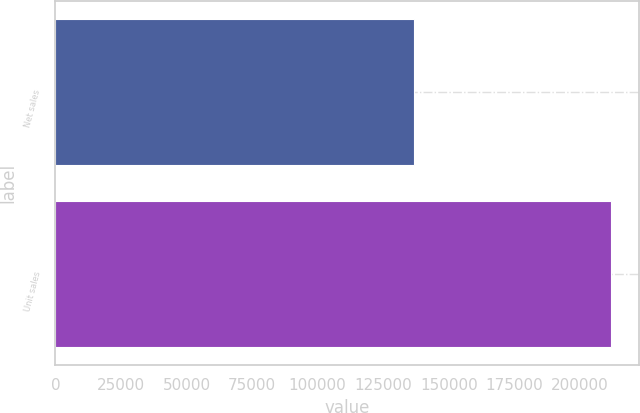Convert chart. <chart><loc_0><loc_0><loc_500><loc_500><bar_chart><fcel>Net sales<fcel>Unit sales<nl><fcel>136700<fcel>211884<nl></chart> 